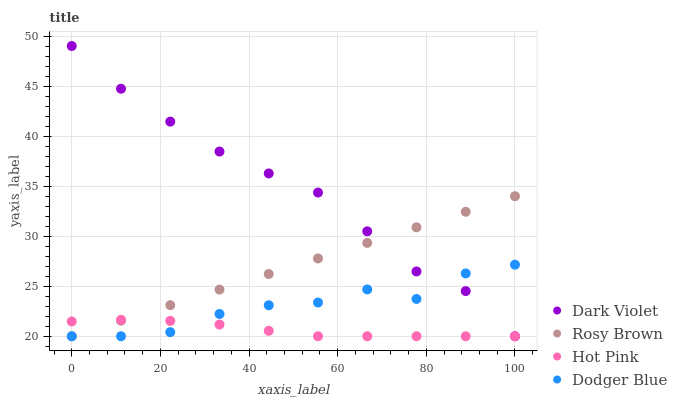Does Hot Pink have the minimum area under the curve?
Answer yes or no. Yes. Does Dark Violet have the maximum area under the curve?
Answer yes or no. Yes. Does Dodger Blue have the minimum area under the curve?
Answer yes or no. No. Does Dodger Blue have the maximum area under the curve?
Answer yes or no. No. Is Rosy Brown the smoothest?
Answer yes or no. Yes. Is Dodger Blue the roughest?
Answer yes or no. Yes. Is Dark Violet the smoothest?
Answer yes or no. No. Is Dark Violet the roughest?
Answer yes or no. No. Does Rosy Brown have the lowest value?
Answer yes or no. Yes. Does Dark Violet have the highest value?
Answer yes or no. Yes. Does Dodger Blue have the highest value?
Answer yes or no. No. Does Dodger Blue intersect Rosy Brown?
Answer yes or no. Yes. Is Dodger Blue less than Rosy Brown?
Answer yes or no. No. Is Dodger Blue greater than Rosy Brown?
Answer yes or no. No. 